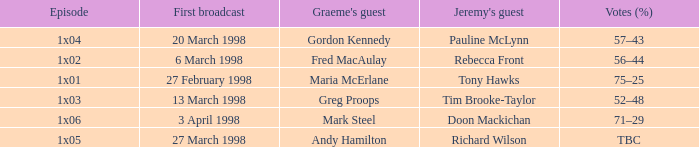What is Votes (%), when Episode is "1x03"? 52–48. 